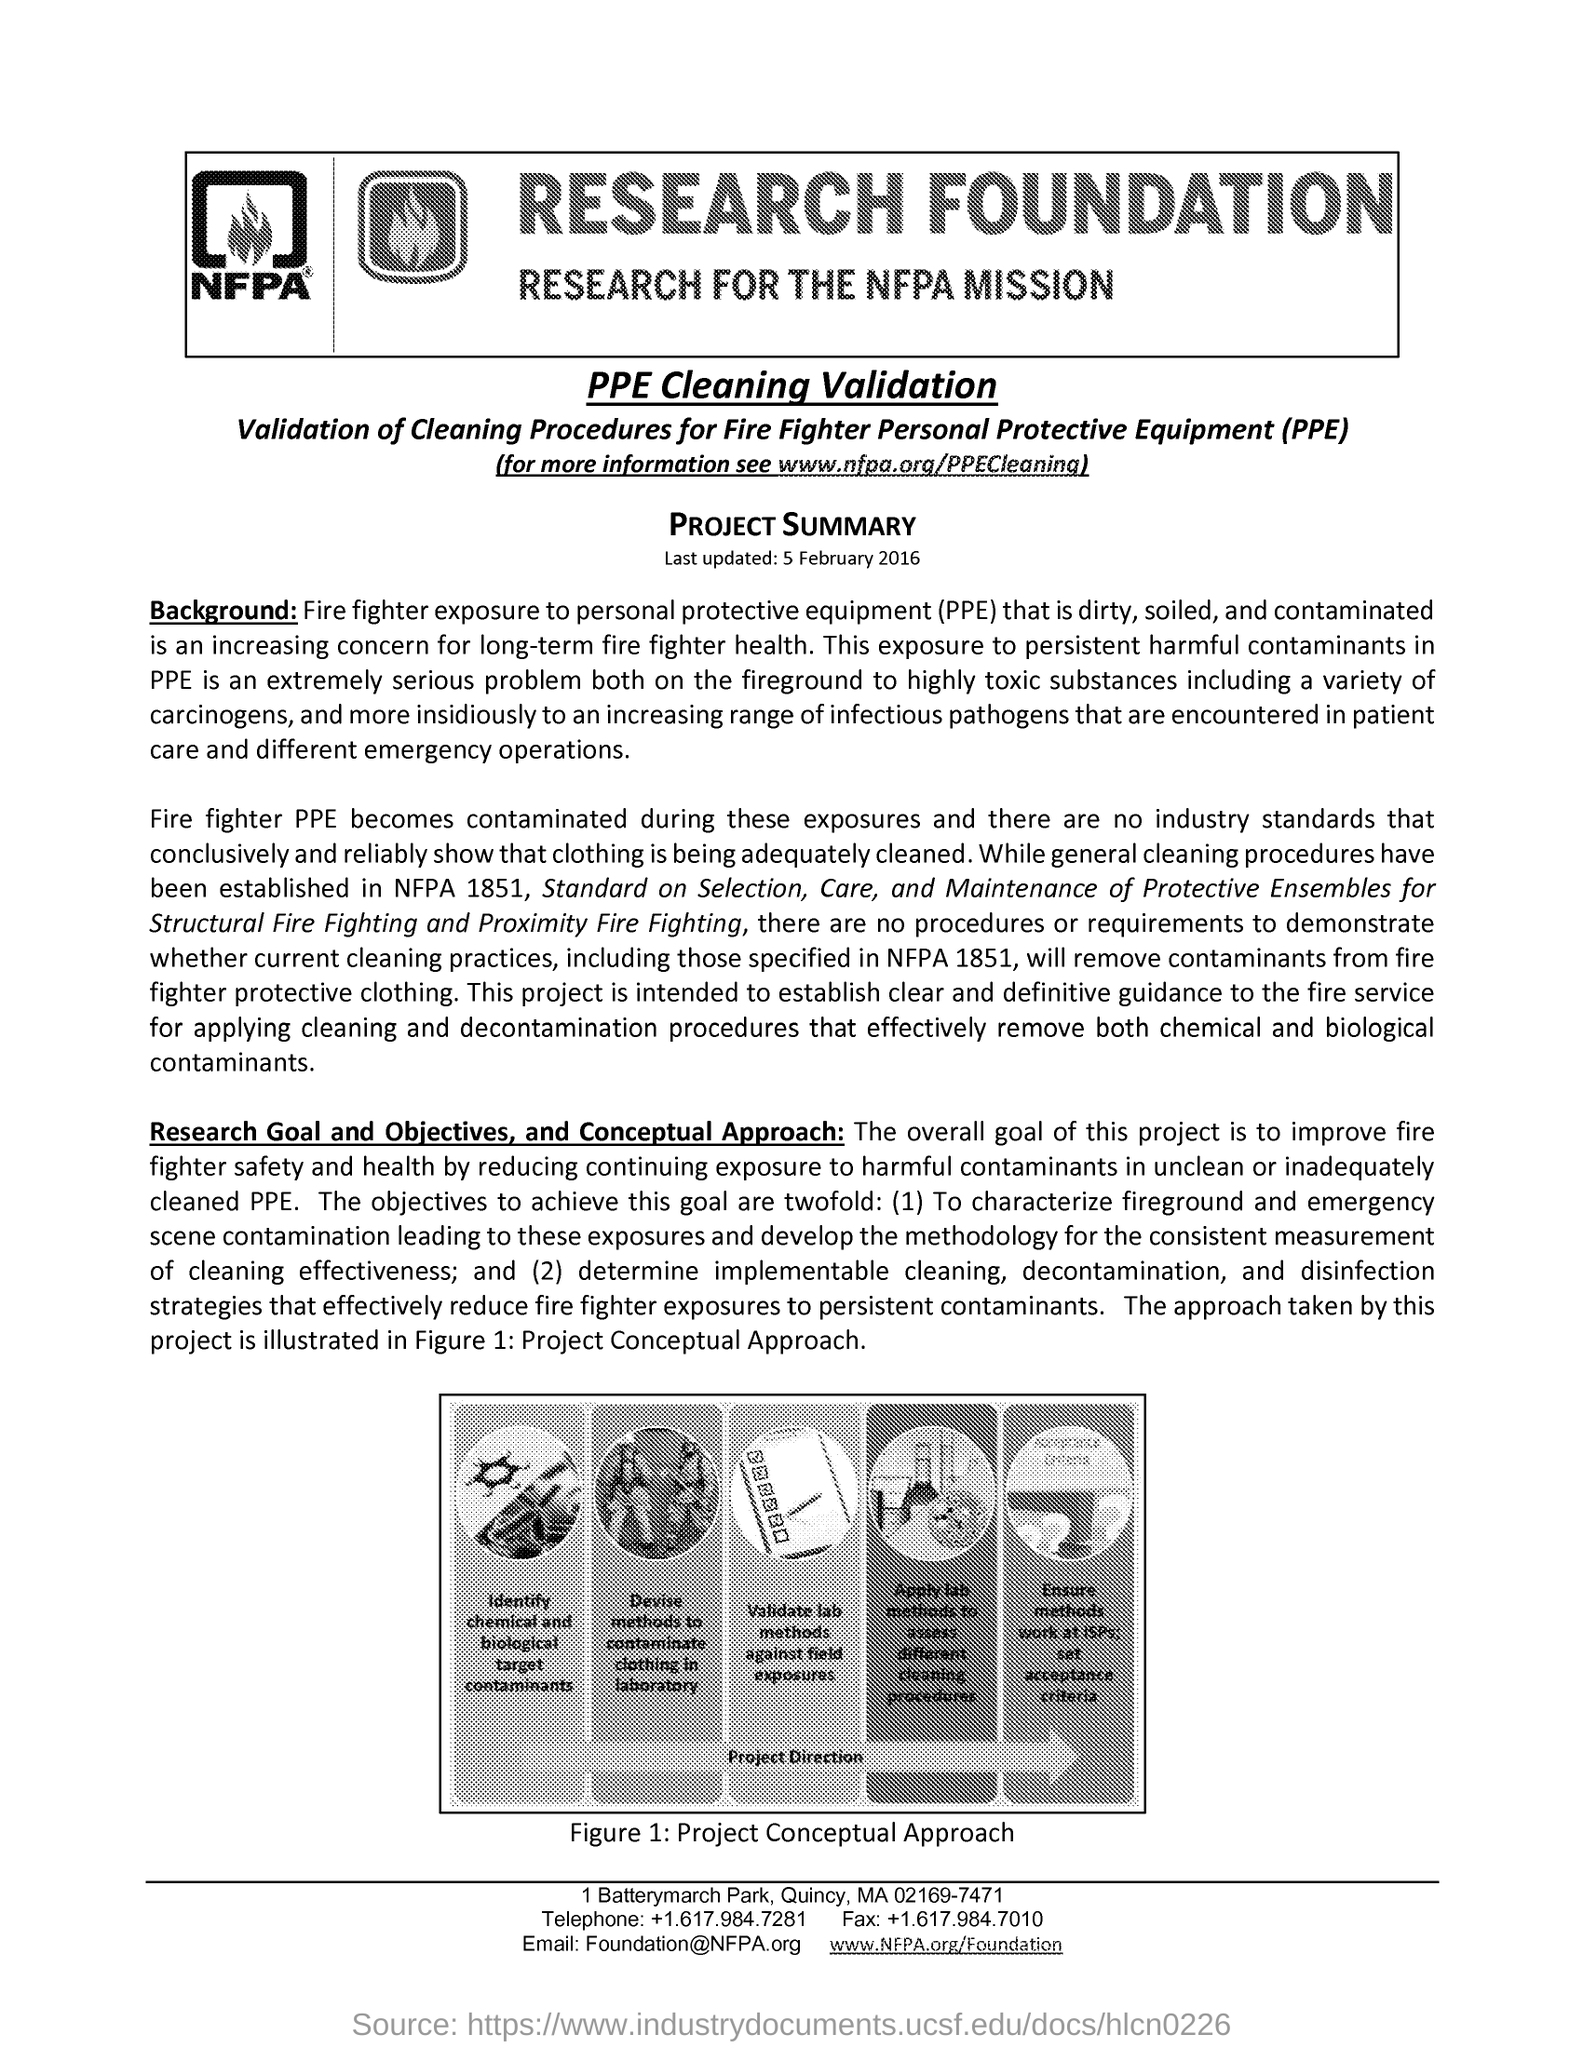Highlight a few significant elements in this photo. The last updated date mentioned in this document is February 5, 2016. Figure 1 represents the project's conceptual approach. I declare that the fullform of PPE is Personal Protective Equipment. 